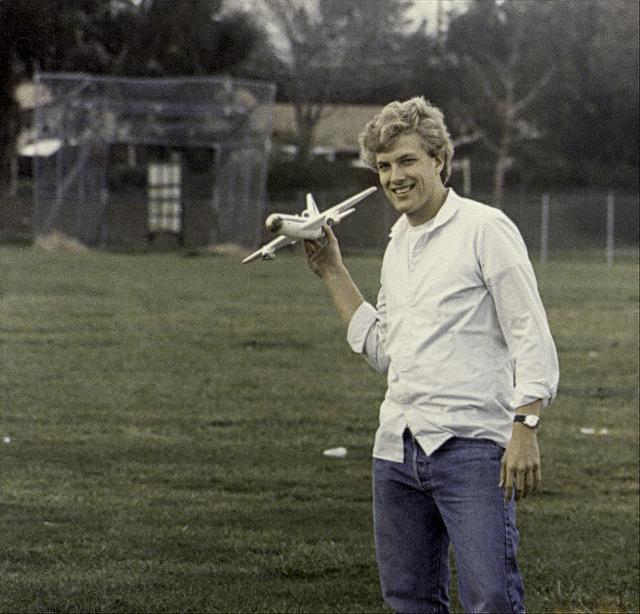Does the image validate the caption "The person is under the airplane."?
Answer yes or no. No. Does the image validate the caption "The airplane is touching the person."?
Answer yes or no. Yes. 